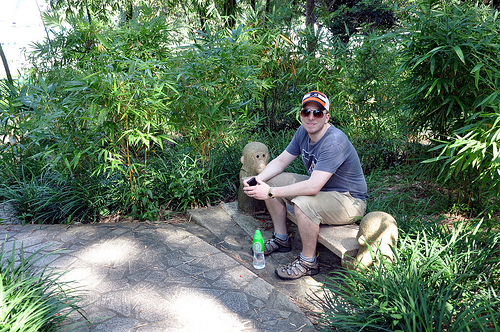<image>
Is the bottle on the chair? No. The bottle is not positioned on the chair. They may be near each other, but the bottle is not supported by or resting on top of the chair. 